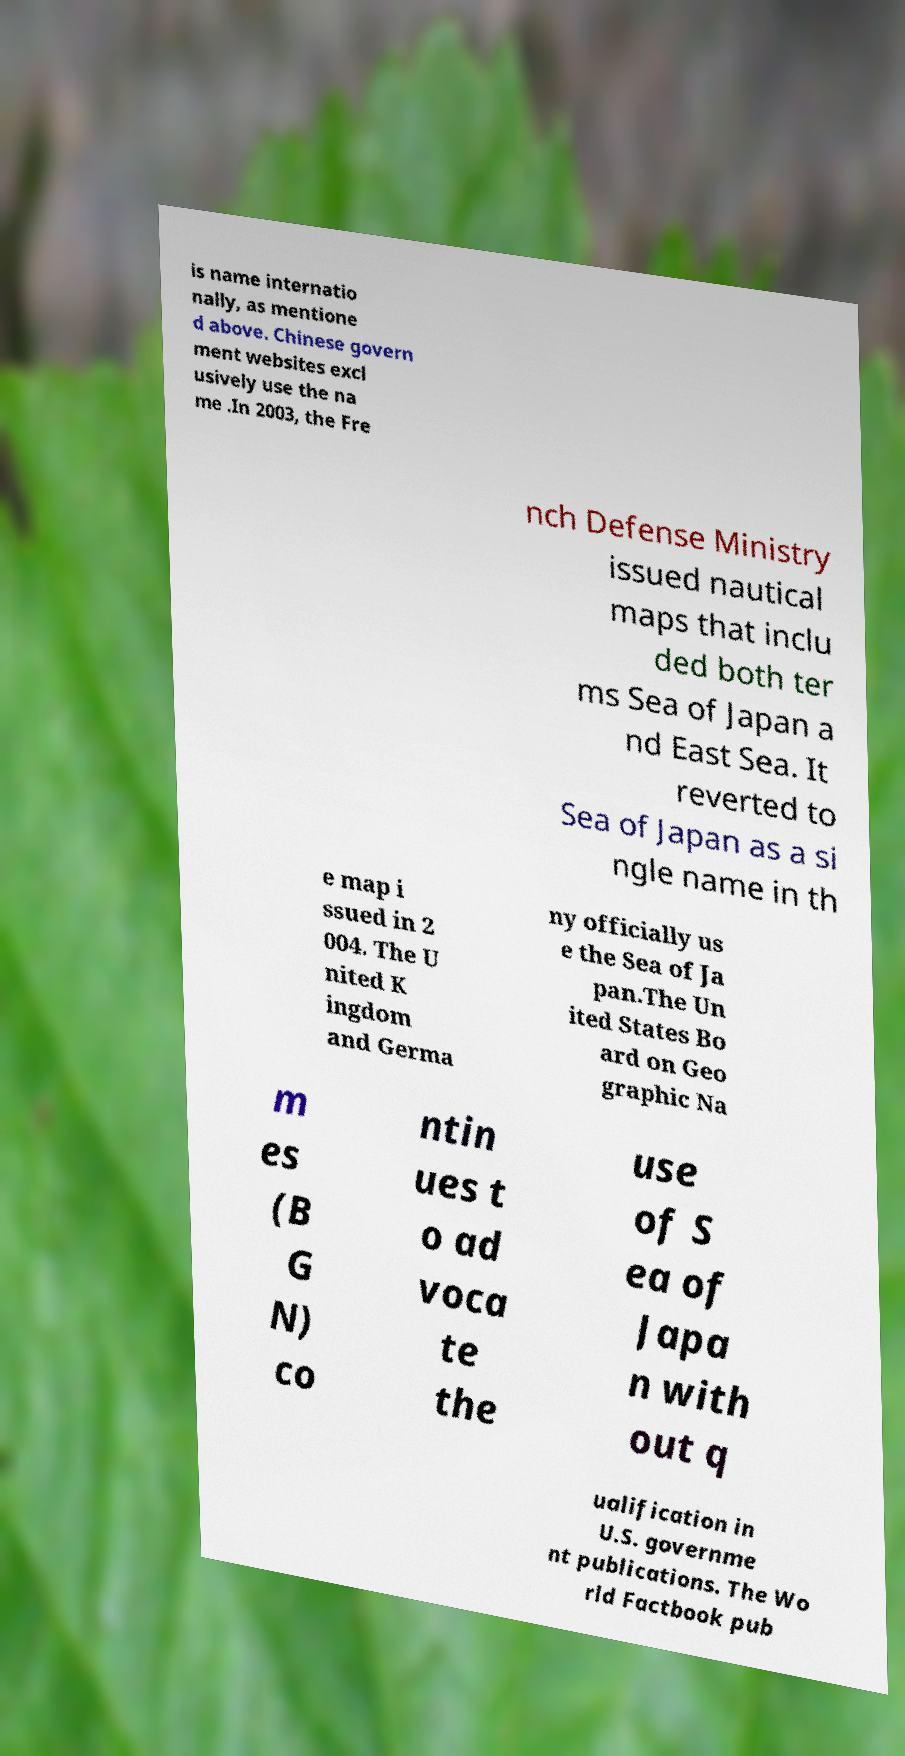Can you read and provide the text displayed in the image?This photo seems to have some interesting text. Can you extract and type it out for me? is name internatio nally, as mentione d above. Chinese govern ment websites excl usively use the na me .In 2003, the Fre nch Defense Ministry issued nautical maps that inclu ded both ter ms Sea of Japan a nd East Sea. It reverted to Sea of Japan as a si ngle name in th e map i ssued in 2 004. The U nited K ingdom and Germa ny officially us e the Sea of Ja pan.The Un ited States Bo ard on Geo graphic Na m es (B G N) co ntin ues t o ad voca te the use of S ea of Japa n with out q ualification in U.S. governme nt publications. The Wo rld Factbook pub 